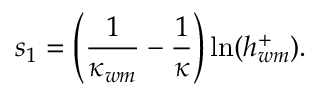Convert formula to latex. <formula><loc_0><loc_0><loc_500><loc_500>s _ { 1 } = \left ( \frac { 1 } { \kappa _ { w m } } - \frac { 1 } { \kappa } \right ) \ln ( h _ { w m } ^ { + } ) .</formula> 